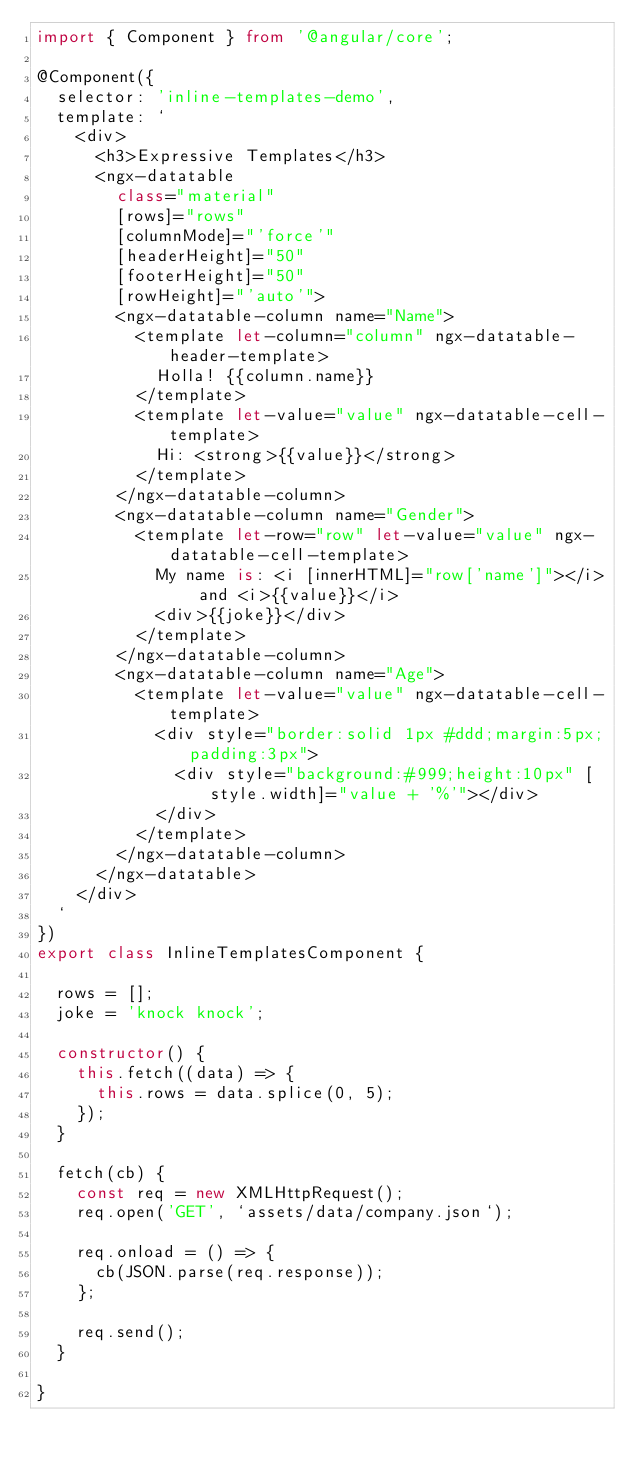<code> <loc_0><loc_0><loc_500><loc_500><_TypeScript_>import { Component } from '@angular/core';

@Component({
  selector: 'inline-templates-demo',
  template: `
    <div>
      <h3>Expressive Templates</h3>
      <ngx-datatable
        class="material"
        [rows]="rows"
        [columnMode]="'force'"
        [headerHeight]="50"
        [footerHeight]="50"
        [rowHeight]="'auto'">
        <ngx-datatable-column name="Name">
          <template let-column="column" ngx-datatable-header-template>
            Holla! {{column.name}}
          </template>
          <template let-value="value" ngx-datatable-cell-template>
            Hi: <strong>{{value}}</strong>
          </template>
        </ngx-datatable-column>
        <ngx-datatable-column name="Gender">
          <template let-row="row" let-value="value" ngx-datatable-cell-template>
            My name is: <i [innerHTML]="row['name']"></i> and <i>{{value}}</i>
            <div>{{joke}}</div>
          </template>
        </ngx-datatable-column>
        <ngx-datatable-column name="Age">
          <template let-value="value" ngx-datatable-cell-template>
            <div style="border:solid 1px #ddd;margin:5px;padding:3px">
              <div style="background:#999;height:10px" [style.width]="value + '%'"></div>
            </div>
          </template>
        </ngx-datatable-column>
      </ngx-datatable>
    </div>
  `
})
export class InlineTemplatesComponent {

  rows = [];
  joke = 'knock knock';

  constructor() {
    this.fetch((data) => {
      this.rows = data.splice(0, 5);
    });
  }

  fetch(cb) {
    const req = new XMLHttpRequest();
    req.open('GET', `assets/data/company.json`);

    req.onload = () => {
      cb(JSON.parse(req.response));
    };

    req.send();
  }

}
</code> 